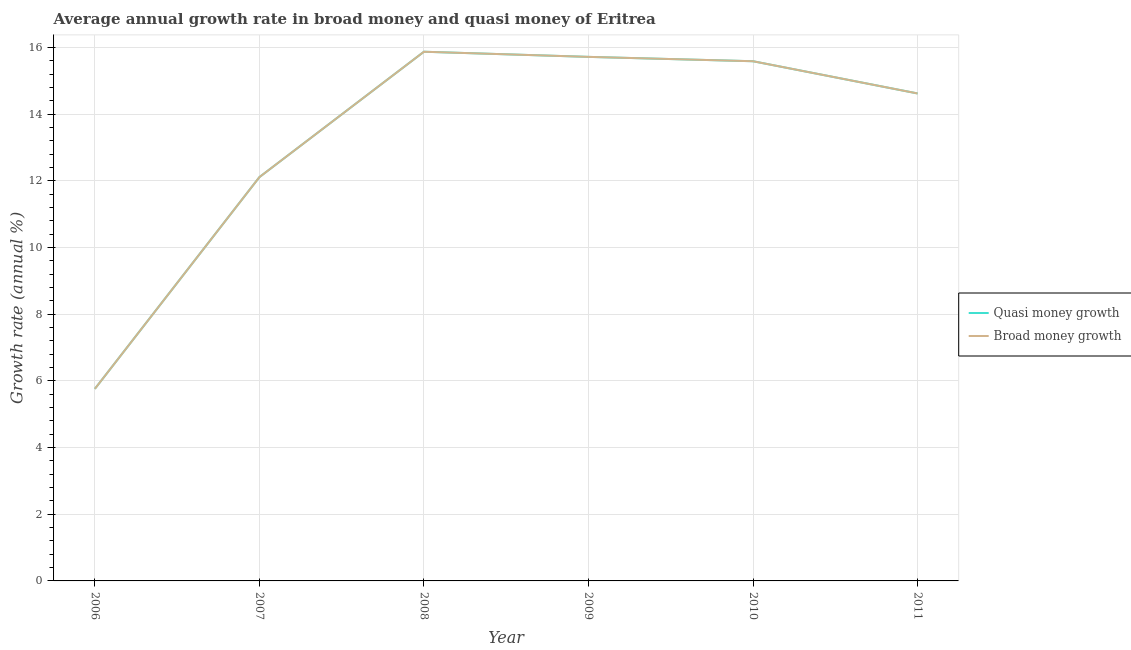What is the annual growth rate in broad money in 2010?
Offer a very short reply. 15.59. Across all years, what is the maximum annual growth rate in broad money?
Offer a terse response. 15.88. Across all years, what is the minimum annual growth rate in broad money?
Ensure brevity in your answer.  5.76. In which year was the annual growth rate in broad money maximum?
Offer a terse response. 2008. What is the total annual growth rate in quasi money in the graph?
Provide a succinct answer. 79.69. What is the difference between the annual growth rate in broad money in 2006 and that in 2008?
Offer a very short reply. -10.11. What is the difference between the annual growth rate in broad money in 2007 and the annual growth rate in quasi money in 2010?
Provide a succinct answer. -3.48. What is the average annual growth rate in quasi money per year?
Provide a succinct answer. 13.28. In how many years, is the annual growth rate in broad money greater than 15.2 %?
Your answer should be compact. 3. What is the ratio of the annual growth rate in quasi money in 2007 to that in 2009?
Your answer should be compact. 0.77. Is the annual growth rate in broad money in 2010 less than that in 2011?
Make the answer very short. No. Is the difference between the annual growth rate in broad money in 2008 and 2010 greater than the difference between the annual growth rate in quasi money in 2008 and 2010?
Your response must be concise. No. What is the difference between the highest and the second highest annual growth rate in broad money?
Make the answer very short. 0.15. What is the difference between the highest and the lowest annual growth rate in broad money?
Make the answer very short. 10.11. Does the annual growth rate in quasi money monotonically increase over the years?
Your answer should be very brief. No. Is the annual growth rate in quasi money strictly less than the annual growth rate in broad money over the years?
Your answer should be compact. No. How many years are there in the graph?
Provide a short and direct response. 6. What is the difference between two consecutive major ticks on the Y-axis?
Provide a succinct answer. 2. Are the values on the major ticks of Y-axis written in scientific E-notation?
Your answer should be very brief. No. Does the graph contain any zero values?
Ensure brevity in your answer.  No. How many legend labels are there?
Offer a terse response. 2. How are the legend labels stacked?
Provide a short and direct response. Vertical. What is the title of the graph?
Provide a short and direct response. Average annual growth rate in broad money and quasi money of Eritrea. Does "Female labor force" appear as one of the legend labels in the graph?
Your response must be concise. No. What is the label or title of the X-axis?
Keep it short and to the point. Year. What is the label or title of the Y-axis?
Your answer should be very brief. Growth rate (annual %). What is the Growth rate (annual %) of Quasi money growth in 2006?
Your response must be concise. 5.76. What is the Growth rate (annual %) of Broad money growth in 2006?
Offer a terse response. 5.76. What is the Growth rate (annual %) in Quasi money growth in 2007?
Your answer should be very brief. 12.11. What is the Growth rate (annual %) in Broad money growth in 2007?
Provide a succinct answer. 12.11. What is the Growth rate (annual %) in Quasi money growth in 2008?
Make the answer very short. 15.88. What is the Growth rate (annual %) in Broad money growth in 2008?
Ensure brevity in your answer.  15.88. What is the Growth rate (annual %) in Quasi money growth in 2009?
Offer a very short reply. 15.72. What is the Growth rate (annual %) of Broad money growth in 2009?
Keep it short and to the point. 15.72. What is the Growth rate (annual %) of Quasi money growth in 2010?
Your response must be concise. 15.59. What is the Growth rate (annual %) in Broad money growth in 2010?
Your answer should be compact. 15.59. What is the Growth rate (annual %) in Quasi money growth in 2011?
Your answer should be compact. 14.62. What is the Growth rate (annual %) in Broad money growth in 2011?
Your answer should be compact. 14.62. Across all years, what is the maximum Growth rate (annual %) of Quasi money growth?
Make the answer very short. 15.88. Across all years, what is the maximum Growth rate (annual %) in Broad money growth?
Give a very brief answer. 15.88. Across all years, what is the minimum Growth rate (annual %) in Quasi money growth?
Your answer should be compact. 5.76. Across all years, what is the minimum Growth rate (annual %) in Broad money growth?
Keep it short and to the point. 5.76. What is the total Growth rate (annual %) of Quasi money growth in the graph?
Keep it short and to the point. 79.69. What is the total Growth rate (annual %) of Broad money growth in the graph?
Your response must be concise. 79.69. What is the difference between the Growth rate (annual %) in Quasi money growth in 2006 and that in 2007?
Your response must be concise. -6.35. What is the difference between the Growth rate (annual %) of Broad money growth in 2006 and that in 2007?
Provide a succinct answer. -6.35. What is the difference between the Growth rate (annual %) of Quasi money growth in 2006 and that in 2008?
Your response must be concise. -10.11. What is the difference between the Growth rate (annual %) of Broad money growth in 2006 and that in 2008?
Offer a very short reply. -10.11. What is the difference between the Growth rate (annual %) in Quasi money growth in 2006 and that in 2009?
Your answer should be very brief. -9.96. What is the difference between the Growth rate (annual %) of Broad money growth in 2006 and that in 2009?
Your response must be concise. -9.96. What is the difference between the Growth rate (annual %) of Quasi money growth in 2006 and that in 2010?
Offer a very short reply. -9.83. What is the difference between the Growth rate (annual %) in Broad money growth in 2006 and that in 2010?
Keep it short and to the point. -9.83. What is the difference between the Growth rate (annual %) of Quasi money growth in 2006 and that in 2011?
Make the answer very short. -8.86. What is the difference between the Growth rate (annual %) in Broad money growth in 2006 and that in 2011?
Your answer should be compact. -8.86. What is the difference between the Growth rate (annual %) of Quasi money growth in 2007 and that in 2008?
Give a very brief answer. -3.76. What is the difference between the Growth rate (annual %) in Broad money growth in 2007 and that in 2008?
Offer a very short reply. -3.76. What is the difference between the Growth rate (annual %) in Quasi money growth in 2007 and that in 2009?
Provide a succinct answer. -3.61. What is the difference between the Growth rate (annual %) of Broad money growth in 2007 and that in 2009?
Your answer should be compact. -3.61. What is the difference between the Growth rate (annual %) in Quasi money growth in 2007 and that in 2010?
Ensure brevity in your answer.  -3.48. What is the difference between the Growth rate (annual %) in Broad money growth in 2007 and that in 2010?
Ensure brevity in your answer.  -3.48. What is the difference between the Growth rate (annual %) in Quasi money growth in 2007 and that in 2011?
Your answer should be very brief. -2.51. What is the difference between the Growth rate (annual %) in Broad money growth in 2007 and that in 2011?
Provide a succinct answer. -2.51. What is the difference between the Growth rate (annual %) in Quasi money growth in 2008 and that in 2009?
Provide a succinct answer. 0.15. What is the difference between the Growth rate (annual %) of Broad money growth in 2008 and that in 2009?
Ensure brevity in your answer.  0.15. What is the difference between the Growth rate (annual %) in Quasi money growth in 2008 and that in 2010?
Offer a very short reply. 0.29. What is the difference between the Growth rate (annual %) in Broad money growth in 2008 and that in 2010?
Your answer should be compact. 0.29. What is the difference between the Growth rate (annual %) in Quasi money growth in 2008 and that in 2011?
Provide a short and direct response. 1.25. What is the difference between the Growth rate (annual %) of Broad money growth in 2008 and that in 2011?
Ensure brevity in your answer.  1.25. What is the difference between the Growth rate (annual %) in Quasi money growth in 2009 and that in 2010?
Ensure brevity in your answer.  0.13. What is the difference between the Growth rate (annual %) of Broad money growth in 2009 and that in 2010?
Make the answer very short. 0.13. What is the difference between the Growth rate (annual %) in Quasi money growth in 2009 and that in 2011?
Your response must be concise. 1.1. What is the difference between the Growth rate (annual %) of Broad money growth in 2009 and that in 2011?
Your answer should be very brief. 1.1. What is the difference between the Growth rate (annual %) in Quasi money growth in 2010 and that in 2011?
Your answer should be compact. 0.97. What is the difference between the Growth rate (annual %) in Broad money growth in 2010 and that in 2011?
Your answer should be very brief. 0.97. What is the difference between the Growth rate (annual %) of Quasi money growth in 2006 and the Growth rate (annual %) of Broad money growth in 2007?
Make the answer very short. -6.35. What is the difference between the Growth rate (annual %) of Quasi money growth in 2006 and the Growth rate (annual %) of Broad money growth in 2008?
Make the answer very short. -10.11. What is the difference between the Growth rate (annual %) in Quasi money growth in 2006 and the Growth rate (annual %) in Broad money growth in 2009?
Keep it short and to the point. -9.96. What is the difference between the Growth rate (annual %) of Quasi money growth in 2006 and the Growth rate (annual %) of Broad money growth in 2010?
Ensure brevity in your answer.  -9.83. What is the difference between the Growth rate (annual %) in Quasi money growth in 2006 and the Growth rate (annual %) in Broad money growth in 2011?
Provide a succinct answer. -8.86. What is the difference between the Growth rate (annual %) in Quasi money growth in 2007 and the Growth rate (annual %) in Broad money growth in 2008?
Give a very brief answer. -3.76. What is the difference between the Growth rate (annual %) in Quasi money growth in 2007 and the Growth rate (annual %) in Broad money growth in 2009?
Offer a terse response. -3.61. What is the difference between the Growth rate (annual %) of Quasi money growth in 2007 and the Growth rate (annual %) of Broad money growth in 2010?
Your response must be concise. -3.48. What is the difference between the Growth rate (annual %) in Quasi money growth in 2007 and the Growth rate (annual %) in Broad money growth in 2011?
Your answer should be compact. -2.51. What is the difference between the Growth rate (annual %) of Quasi money growth in 2008 and the Growth rate (annual %) of Broad money growth in 2009?
Offer a terse response. 0.15. What is the difference between the Growth rate (annual %) of Quasi money growth in 2008 and the Growth rate (annual %) of Broad money growth in 2010?
Offer a very short reply. 0.29. What is the difference between the Growth rate (annual %) in Quasi money growth in 2008 and the Growth rate (annual %) in Broad money growth in 2011?
Provide a short and direct response. 1.25. What is the difference between the Growth rate (annual %) of Quasi money growth in 2009 and the Growth rate (annual %) of Broad money growth in 2010?
Your answer should be compact. 0.13. What is the difference between the Growth rate (annual %) of Quasi money growth in 2009 and the Growth rate (annual %) of Broad money growth in 2011?
Your response must be concise. 1.1. What is the difference between the Growth rate (annual %) of Quasi money growth in 2010 and the Growth rate (annual %) of Broad money growth in 2011?
Make the answer very short. 0.97. What is the average Growth rate (annual %) of Quasi money growth per year?
Keep it short and to the point. 13.28. What is the average Growth rate (annual %) of Broad money growth per year?
Ensure brevity in your answer.  13.28. In the year 2006, what is the difference between the Growth rate (annual %) in Quasi money growth and Growth rate (annual %) in Broad money growth?
Provide a succinct answer. 0. In the year 2007, what is the difference between the Growth rate (annual %) of Quasi money growth and Growth rate (annual %) of Broad money growth?
Make the answer very short. 0. In the year 2008, what is the difference between the Growth rate (annual %) of Quasi money growth and Growth rate (annual %) of Broad money growth?
Provide a short and direct response. 0. In the year 2009, what is the difference between the Growth rate (annual %) of Quasi money growth and Growth rate (annual %) of Broad money growth?
Offer a terse response. 0. In the year 2010, what is the difference between the Growth rate (annual %) of Quasi money growth and Growth rate (annual %) of Broad money growth?
Offer a terse response. 0. In the year 2011, what is the difference between the Growth rate (annual %) in Quasi money growth and Growth rate (annual %) in Broad money growth?
Ensure brevity in your answer.  0. What is the ratio of the Growth rate (annual %) of Quasi money growth in 2006 to that in 2007?
Offer a terse response. 0.48. What is the ratio of the Growth rate (annual %) in Broad money growth in 2006 to that in 2007?
Ensure brevity in your answer.  0.48. What is the ratio of the Growth rate (annual %) in Quasi money growth in 2006 to that in 2008?
Offer a very short reply. 0.36. What is the ratio of the Growth rate (annual %) of Broad money growth in 2006 to that in 2008?
Make the answer very short. 0.36. What is the ratio of the Growth rate (annual %) in Quasi money growth in 2006 to that in 2009?
Give a very brief answer. 0.37. What is the ratio of the Growth rate (annual %) of Broad money growth in 2006 to that in 2009?
Your answer should be compact. 0.37. What is the ratio of the Growth rate (annual %) of Quasi money growth in 2006 to that in 2010?
Keep it short and to the point. 0.37. What is the ratio of the Growth rate (annual %) of Broad money growth in 2006 to that in 2010?
Give a very brief answer. 0.37. What is the ratio of the Growth rate (annual %) in Quasi money growth in 2006 to that in 2011?
Provide a short and direct response. 0.39. What is the ratio of the Growth rate (annual %) in Broad money growth in 2006 to that in 2011?
Give a very brief answer. 0.39. What is the ratio of the Growth rate (annual %) in Quasi money growth in 2007 to that in 2008?
Your answer should be very brief. 0.76. What is the ratio of the Growth rate (annual %) of Broad money growth in 2007 to that in 2008?
Give a very brief answer. 0.76. What is the ratio of the Growth rate (annual %) in Quasi money growth in 2007 to that in 2009?
Your answer should be compact. 0.77. What is the ratio of the Growth rate (annual %) of Broad money growth in 2007 to that in 2009?
Offer a very short reply. 0.77. What is the ratio of the Growth rate (annual %) in Quasi money growth in 2007 to that in 2010?
Your answer should be compact. 0.78. What is the ratio of the Growth rate (annual %) of Broad money growth in 2007 to that in 2010?
Give a very brief answer. 0.78. What is the ratio of the Growth rate (annual %) in Quasi money growth in 2007 to that in 2011?
Give a very brief answer. 0.83. What is the ratio of the Growth rate (annual %) of Broad money growth in 2007 to that in 2011?
Offer a terse response. 0.83. What is the ratio of the Growth rate (annual %) of Quasi money growth in 2008 to that in 2009?
Offer a very short reply. 1.01. What is the ratio of the Growth rate (annual %) in Broad money growth in 2008 to that in 2009?
Offer a very short reply. 1.01. What is the ratio of the Growth rate (annual %) of Quasi money growth in 2008 to that in 2010?
Offer a terse response. 1.02. What is the ratio of the Growth rate (annual %) in Broad money growth in 2008 to that in 2010?
Your response must be concise. 1.02. What is the ratio of the Growth rate (annual %) in Quasi money growth in 2008 to that in 2011?
Keep it short and to the point. 1.09. What is the ratio of the Growth rate (annual %) in Broad money growth in 2008 to that in 2011?
Keep it short and to the point. 1.09. What is the ratio of the Growth rate (annual %) of Quasi money growth in 2009 to that in 2010?
Your answer should be compact. 1.01. What is the ratio of the Growth rate (annual %) of Broad money growth in 2009 to that in 2010?
Make the answer very short. 1.01. What is the ratio of the Growth rate (annual %) in Quasi money growth in 2009 to that in 2011?
Provide a succinct answer. 1.07. What is the ratio of the Growth rate (annual %) of Broad money growth in 2009 to that in 2011?
Keep it short and to the point. 1.07. What is the ratio of the Growth rate (annual %) in Quasi money growth in 2010 to that in 2011?
Ensure brevity in your answer.  1.07. What is the ratio of the Growth rate (annual %) in Broad money growth in 2010 to that in 2011?
Your answer should be compact. 1.07. What is the difference between the highest and the second highest Growth rate (annual %) in Quasi money growth?
Keep it short and to the point. 0.15. What is the difference between the highest and the second highest Growth rate (annual %) in Broad money growth?
Your answer should be very brief. 0.15. What is the difference between the highest and the lowest Growth rate (annual %) of Quasi money growth?
Ensure brevity in your answer.  10.11. What is the difference between the highest and the lowest Growth rate (annual %) of Broad money growth?
Provide a succinct answer. 10.11. 